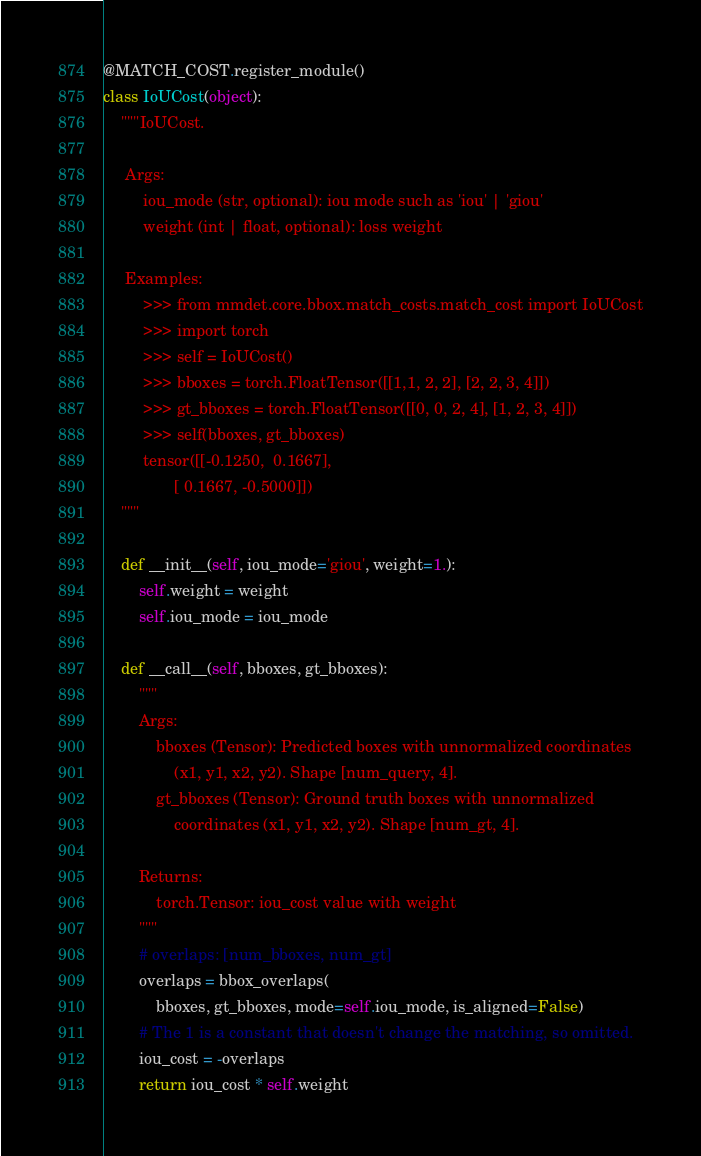<code> <loc_0><loc_0><loc_500><loc_500><_Python_>@MATCH_COST.register_module()
class IoUCost(object):
    """IoUCost.

     Args:
         iou_mode (str, optional): iou mode such as 'iou' | 'giou'
         weight (int | float, optional): loss weight

     Examples:
         >>> from mmdet.core.bbox.match_costs.match_cost import IoUCost
         >>> import torch
         >>> self = IoUCost()
         >>> bboxes = torch.FloatTensor([[1,1, 2, 2], [2, 2, 3, 4]])
         >>> gt_bboxes = torch.FloatTensor([[0, 0, 2, 4], [1, 2, 3, 4]])
         >>> self(bboxes, gt_bboxes)
         tensor([[-0.1250,  0.1667],
                [ 0.1667, -0.5000]])
    """

    def __init__(self, iou_mode='giou', weight=1.):
        self.weight = weight
        self.iou_mode = iou_mode

    def __call__(self, bboxes, gt_bboxes):
        """
        Args:
            bboxes (Tensor): Predicted boxes with unnormalized coordinates
                (x1, y1, x2, y2). Shape [num_query, 4].
            gt_bboxes (Tensor): Ground truth boxes with unnormalized
                coordinates (x1, y1, x2, y2). Shape [num_gt, 4].

        Returns:
            torch.Tensor: iou_cost value with weight
        """
        # overlaps: [num_bboxes, num_gt]
        overlaps = bbox_overlaps(
            bboxes, gt_bboxes, mode=self.iou_mode, is_aligned=False)
        # The 1 is a constant that doesn't change the matching, so omitted.
        iou_cost = -overlaps
        return iou_cost * self.weight
</code> 